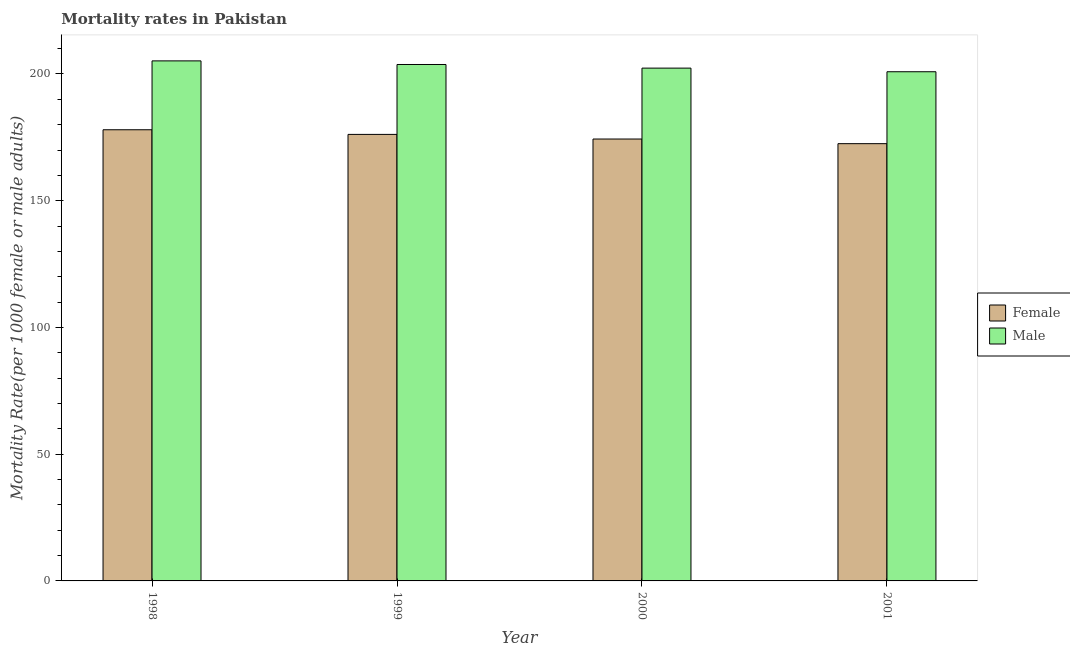How many different coloured bars are there?
Your answer should be very brief. 2. How many groups of bars are there?
Offer a very short reply. 4. Are the number of bars on each tick of the X-axis equal?
Offer a terse response. Yes. What is the label of the 4th group of bars from the left?
Your response must be concise. 2001. In how many cases, is the number of bars for a given year not equal to the number of legend labels?
Provide a short and direct response. 0. What is the male mortality rate in 2001?
Provide a short and direct response. 200.89. Across all years, what is the maximum male mortality rate?
Provide a succinct answer. 205.17. Across all years, what is the minimum female mortality rate?
Keep it short and to the point. 172.51. In which year was the female mortality rate minimum?
Offer a very short reply. 2001. What is the total female mortality rate in the graph?
Keep it short and to the point. 701.01. What is the difference between the female mortality rate in 1999 and that in 2000?
Provide a short and direct response. 1.83. What is the difference between the female mortality rate in 1998 and the male mortality rate in 1999?
Keep it short and to the point. 1.83. What is the average female mortality rate per year?
Offer a terse response. 175.25. In the year 2000, what is the difference between the male mortality rate and female mortality rate?
Provide a short and direct response. 0. What is the ratio of the male mortality rate in 1999 to that in 2000?
Offer a very short reply. 1.01. Is the difference between the male mortality rate in 2000 and 2001 greater than the difference between the female mortality rate in 2000 and 2001?
Make the answer very short. No. What is the difference between the highest and the second highest male mortality rate?
Offer a very short reply. 1.43. What is the difference between the highest and the lowest female mortality rate?
Provide a short and direct response. 5.49. In how many years, is the female mortality rate greater than the average female mortality rate taken over all years?
Make the answer very short. 2. What does the 1st bar from the right in 2000 represents?
Keep it short and to the point. Male. How many bars are there?
Your answer should be very brief. 8. Are all the bars in the graph horizontal?
Provide a short and direct response. No. How many years are there in the graph?
Give a very brief answer. 4. What is the difference between two consecutive major ticks on the Y-axis?
Ensure brevity in your answer.  50. Does the graph contain any zero values?
Your response must be concise. No. How many legend labels are there?
Offer a very short reply. 2. How are the legend labels stacked?
Provide a succinct answer. Vertical. What is the title of the graph?
Offer a very short reply. Mortality rates in Pakistan. Does "Investments" appear as one of the legend labels in the graph?
Your response must be concise. No. What is the label or title of the X-axis?
Give a very brief answer. Year. What is the label or title of the Y-axis?
Your answer should be very brief. Mortality Rate(per 1000 female or male adults). What is the Mortality Rate(per 1000 female or male adults) of Female in 1998?
Your answer should be compact. 178. What is the Mortality Rate(per 1000 female or male adults) in Male in 1998?
Give a very brief answer. 205.17. What is the Mortality Rate(per 1000 female or male adults) in Female in 1999?
Offer a terse response. 176.17. What is the Mortality Rate(per 1000 female or male adults) in Male in 1999?
Give a very brief answer. 203.75. What is the Mortality Rate(per 1000 female or male adults) in Female in 2000?
Provide a succinct answer. 174.34. What is the Mortality Rate(per 1000 female or male adults) in Male in 2000?
Make the answer very short. 202.32. What is the Mortality Rate(per 1000 female or male adults) of Female in 2001?
Your answer should be very brief. 172.51. What is the Mortality Rate(per 1000 female or male adults) of Male in 2001?
Provide a succinct answer. 200.89. Across all years, what is the maximum Mortality Rate(per 1000 female or male adults) in Female?
Provide a short and direct response. 178. Across all years, what is the maximum Mortality Rate(per 1000 female or male adults) of Male?
Your answer should be compact. 205.17. Across all years, what is the minimum Mortality Rate(per 1000 female or male adults) in Female?
Offer a very short reply. 172.51. Across all years, what is the minimum Mortality Rate(per 1000 female or male adults) of Male?
Keep it short and to the point. 200.89. What is the total Mortality Rate(per 1000 female or male adults) of Female in the graph?
Offer a very short reply. 701.01. What is the total Mortality Rate(per 1000 female or male adults) in Male in the graph?
Provide a succinct answer. 812.12. What is the difference between the Mortality Rate(per 1000 female or male adults) in Female in 1998 and that in 1999?
Your answer should be compact. 1.83. What is the difference between the Mortality Rate(per 1000 female or male adults) in Male in 1998 and that in 1999?
Make the answer very short. 1.43. What is the difference between the Mortality Rate(per 1000 female or male adults) in Female in 1998 and that in 2000?
Your answer should be very brief. 3.66. What is the difference between the Mortality Rate(per 1000 female or male adults) in Male in 1998 and that in 2000?
Make the answer very short. 2.86. What is the difference between the Mortality Rate(per 1000 female or male adults) in Female in 1998 and that in 2001?
Your answer should be very brief. 5.49. What is the difference between the Mortality Rate(per 1000 female or male adults) of Male in 1998 and that in 2001?
Give a very brief answer. 4.28. What is the difference between the Mortality Rate(per 1000 female or male adults) in Female in 1999 and that in 2000?
Your answer should be compact. 1.83. What is the difference between the Mortality Rate(per 1000 female or male adults) in Male in 1999 and that in 2000?
Offer a very short reply. 1.43. What is the difference between the Mortality Rate(per 1000 female or male adults) of Female in 1999 and that in 2001?
Make the answer very short. 3.66. What is the difference between the Mortality Rate(per 1000 female or male adults) in Male in 1999 and that in 2001?
Offer a terse response. 2.86. What is the difference between the Mortality Rate(per 1000 female or male adults) in Female in 2000 and that in 2001?
Your answer should be very brief. 1.83. What is the difference between the Mortality Rate(per 1000 female or male adults) of Male in 2000 and that in 2001?
Your answer should be very brief. 1.43. What is the difference between the Mortality Rate(per 1000 female or male adults) in Female in 1998 and the Mortality Rate(per 1000 female or male adults) in Male in 1999?
Offer a terse response. -25.75. What is the difference between the Mortality Rate(per 1000 female or male adults) in Female in 1998 and the Mortality Rate(per 1000 female or male adults) in Male in 2000?
Make the answer very short. -24.32. What is the difference between the Mortality Rate(per 1000 female or male adults) of Female in 1998 and the Mortality Rate(per 1000 female or male adults) of Male in 2001?
Offer a very short reply. -22.89. What is the difference between the Mortality Rate(per 1000 female or male adults) of Female in 1999 and the Mortality Rate(per 1000 female or male adults) of Male in 2000?
Provide a short and direct response. -26.15. What is the difference between the Mortality Rate(per 1000 female or male adults) of Female in 1999 and the Mortality Rate(per 1000 female or male adults) of Male in 2001?
Make the answer very short. -24.72. What is the difference between the Mortality Rate(per 1000 female or male adults) in Female in 2000 and the Mortality Rate(per 1000 female or male adults) in Male in 2001?
Make the answer very short. -26.55. What is the average Mortality Rate(per 1000 female or male adults) in Female per year?
Ensure brevity in your answer.  175.25. What is the average Mortality Rate(per 1000 female or male adults) of Male per year?
Provide a succinct answer. 203.03. In the year 1998, what is the difference between the Mortality Rate(per 1000 female or male adults) of Female and Mortality Rate(per 1000 female or male adults) of Male?
Make the answer very short. -27.18. In the year 1999, what is the difference between the Mortality Rate(per 1000 female or male adults) in Female and Mortality Rate(per 1000 female or male adults) in Male?
Your response must be concise. -27.58. In the year 2000, what is the difference between the Mortality Rate(per 1000 female or male adults) in Female and Mortality Rate(per 1000 female or male adults) in Male?
Offer a terse response. -27.98. In the year 2001, what is the difference between the Mortality Rate(per 1000 female or male adults) in Female and Mortality Rate(per 1000 female or male adults) in Male?
Your answer should be compact. -28.38. What is the ratio of the Mortality Rate(per 1000 female or male adults) of Female in 1998 to that in 1999?
Ensure brevity in your answer.  1.01. What is the ratio of the Mortality Rate(per 1000 female or male adults) of Female in 1998 to that in 2000?
Your response must be concise. 1.02. What is the ratio of the Mortality Rate(per 1000 female or male adults) of Male in 1998 to that in 2000?
Ensure brevity in your answer.  1.01. What is the ratio of the Mortality Rate(per 1000 female or male adults) in Female in 1998 to that in 2001?
Provide a succinct answer. 1.03. What is the ratio of the Mortality Rate(per 1000 female or male adults) in Male in 1998 to that in 2001?
Your answer should be very brief. 1.02. What is the ratio of the Mortality Rate(per 1000 female or male adults) in Female in 1999 to that in 2000?
Provide a succinct answer. 1.01. What is the ratio of the Mortality Rate(per 1000 female or male adults) in Male in 1999 to that in 2000?
Give a very brief answer. 1.01. What is the ratio of the Mortality Rate(per 1000 female or male adults) in Female in 1999 to that in 2001?
Offer a very short reply. 1.02. What is the ratio of the Mortality Rate(per 1000 female or male adults) of Male in 1999 to that in 2001?
Make the answer very short. 1.01. What is the ratio of the Mortality Rate(per 1000 female or male adults) in Female in 2000 to that in 2001?
Your answer should be very brief. 1.01. What is the ratio of the Mortality Rate(per 1000 female or male adults) of Male in 2000 to that in 2001?
Make the answer very short. 1.01. What is the difference between the highest and the second highest Mortality Rate(per 1000 female or male adults) in Female?
Offer a terse response. 1.83. What is the difference between the highest and the second highest Mortality Rate(per 1000 female or male adults) in Male?
Your answer should be very brief. 1.43. What is the difference between the highest and the lowest Mortality Rate(per 1000 female or male adults) in Female?
Provide a succinct answer. 5.49. What is the difference between the highest and the lowest Mortality Rate(per 1000 female or male adults) in Male?
Give a very brief answer. 4.28. 